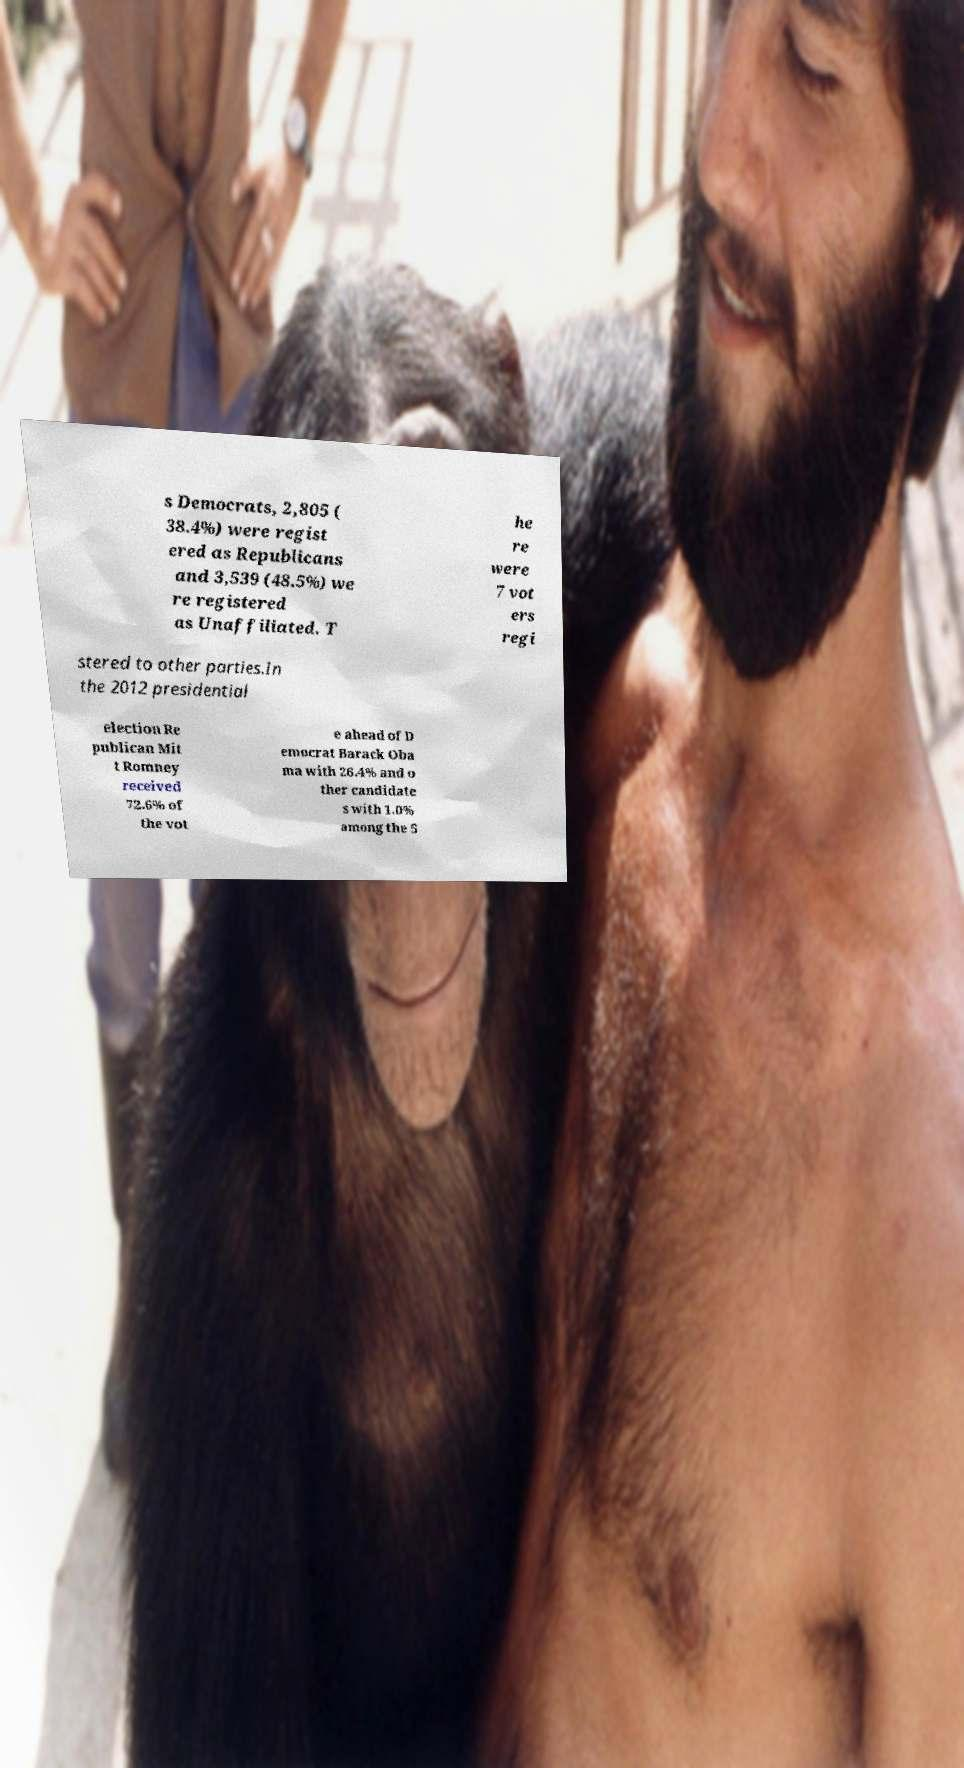Please identify and transcribe the text found in this image. s Democrats, 2,805 ( 38.4%) were regist ered as Republicans and 3,539 (48.5%) we re registered as Unaffiliated. T he re were 7 vot ers regi stered to other parties.In the 2012 presidential election Re publican Mit t Romney received 72.6% of the vot e ahead of D emocrat Barack Oba ma with 26.4% and o ther candidate s with 1.0% among the 5 